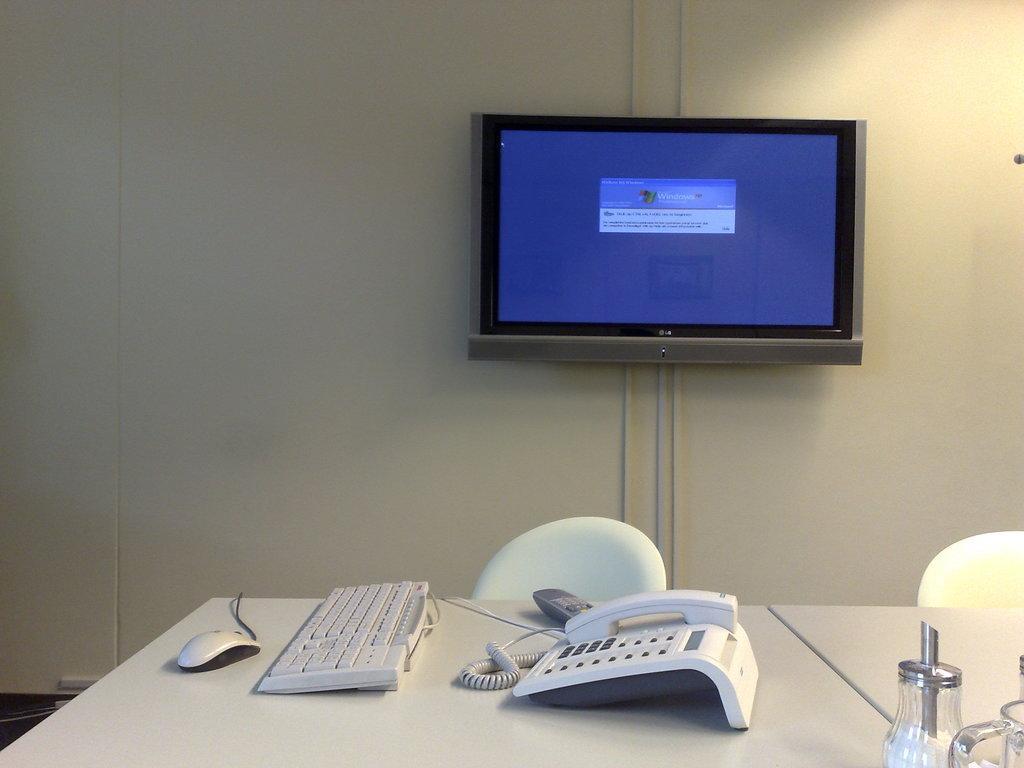In one or two sentences, can you explain what this image depicts? A monitor is fixed to the wall. The Mouse, keyboard,a remote control and a telephone are placed on a table. There are two chairs beside the table. 